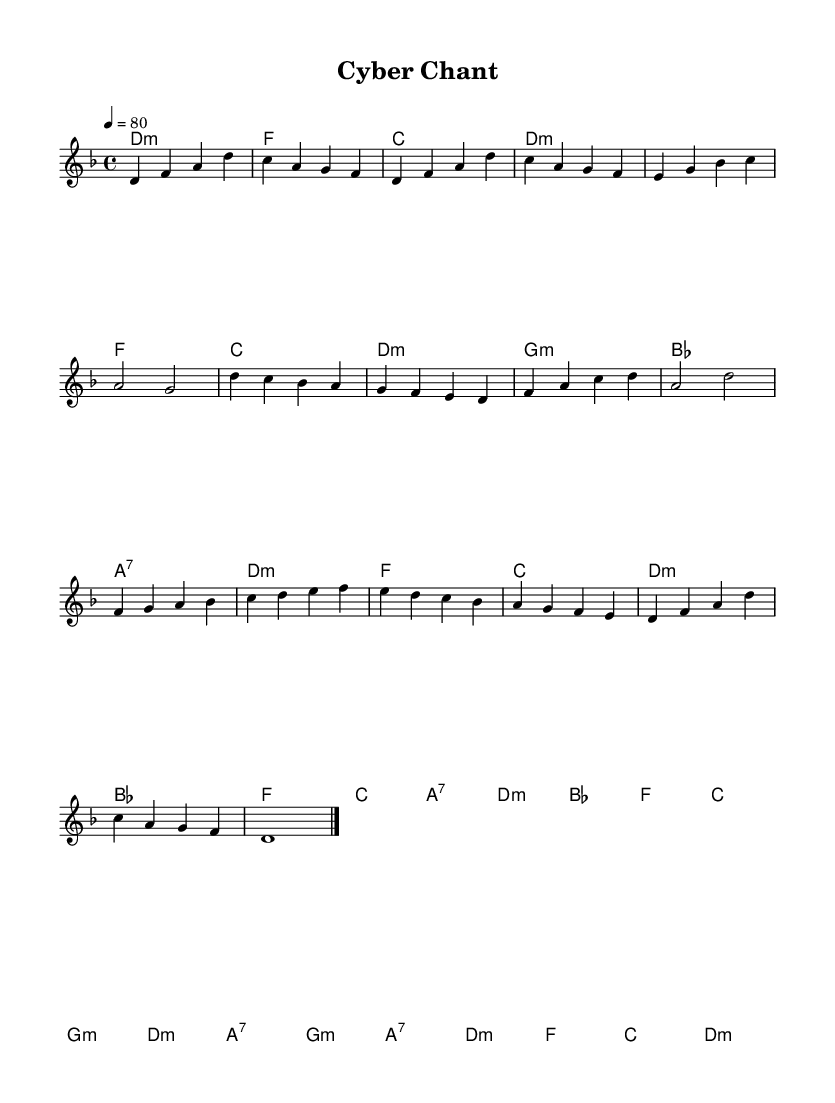What is the key signature of this music? The key signature is determined by the sharps or flats shown at the beginning of the staff. Since there are no accidentals present, the key is D minor, which has one flat.
Answer: D minor What is the time signature of the piece? The time signature appears at the beginning of the staff. It is represented as 4/4, meaning four beats per measure and a quarter note gets one beat.
Answer: 4/4 What is the tempo marking of the music? The tempo marking shows a metronome indication, which is typically placed above the staff. Here, it indicates 80 beats per minute, showing that the music should be played at a moderate pace.
Answer: 80 How many measures are in the 'Chorus' section? To find the number of measures in the 'Chorus,' count the number of vertical bar lines separating the notes in that section. There are four measures.
Answer: 4 What type of harmony is predominantly used throughout the piece? By examining the harmony notations, we can see they consist of mostly minor chords, indicating the piece predominantly uses minor harmonies, which is characteristic for Gregorian chants.
Answer: Minor How does the melody in the 'Bridge' section differ from the 'Verse' section in terms of notes? Comparing the notes of both sections, in the 'Bridge,' there is a shift to a higher pitch range (starting on F), and it contains notes that ascend more than in the 'Verse' section, which is more stable and grounded.
Answer: Ascending pitch What overall genre does this piece belong to? The combination of Gregorian chant elements with electronic influences suggests a modern adaptation of traditional religious music, so the genre can be classified broadly as electronic sacred music.
Answer: Electronic sacred music 